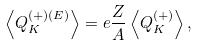<formula> <loc_0><loc_0><loc_500><loc_500>\left \langle Q _ { K } ^ { ( + ) ( E ) } \right \rangle = e \frac { Z } { A } \left \langle Q _ { K } ^ { ( + ) } \right \rangle ,</formula> 